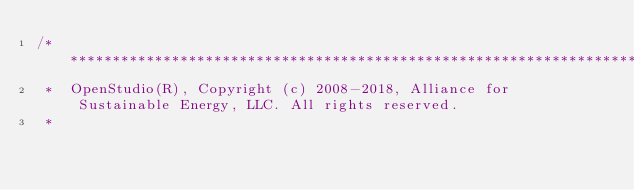Convert code to text. <code><loc_0><loc_0><loc_500><loc_500><_C++_>/***********************************************************************************************************************
 *  OpenStudio(R), Copyright (c) 2008-2018, Alliance for Sustainable Energy, LLC. All rights reserved.
 *</code> 